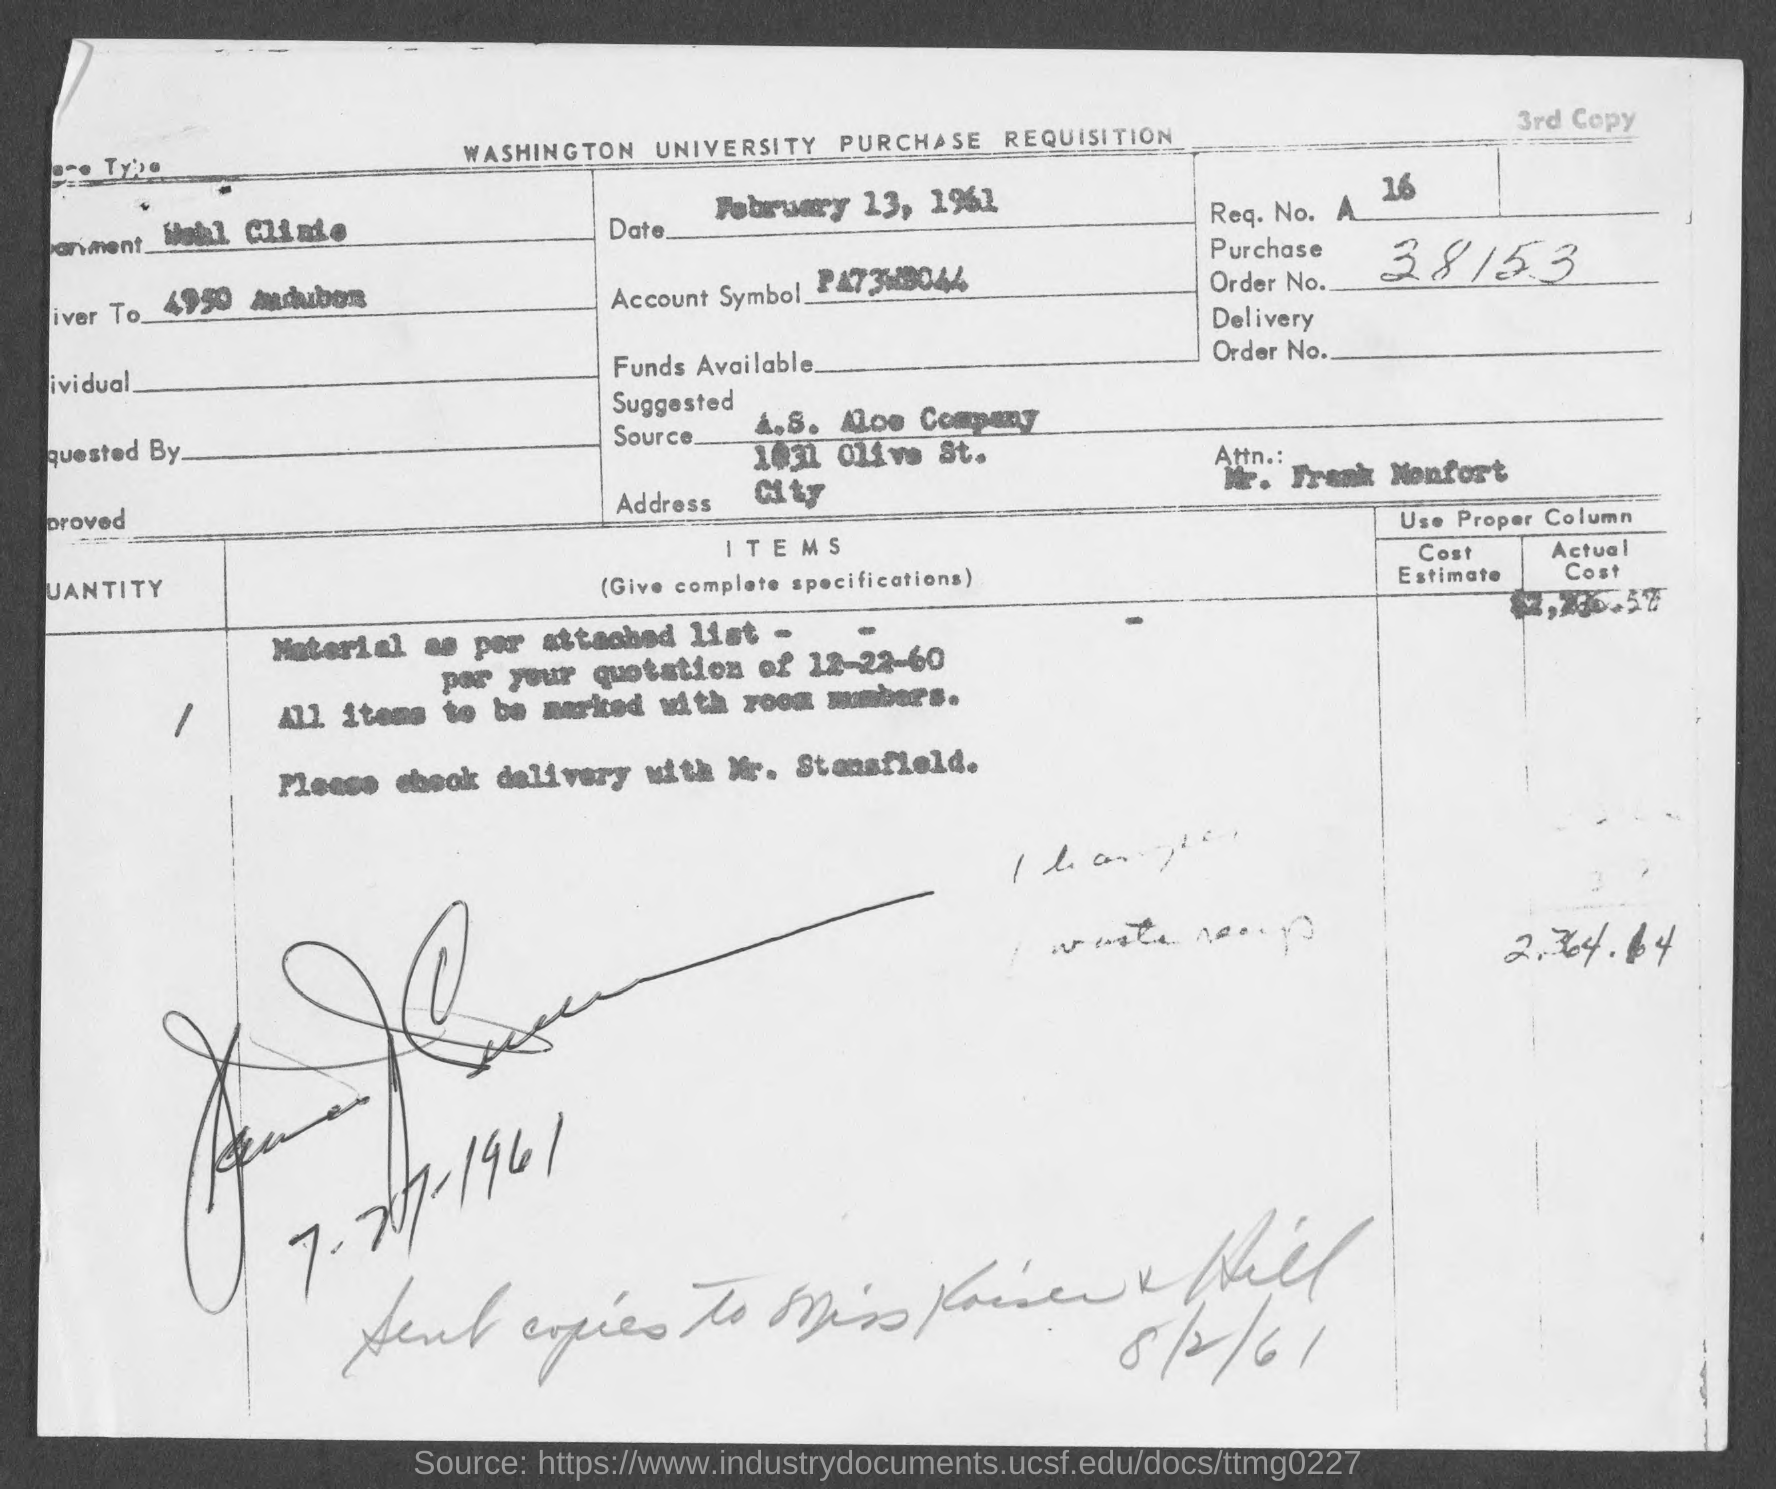Give some essential details in this illustration. The order number is 38153 and it consists of a sequence of numbers that continue until the end. 